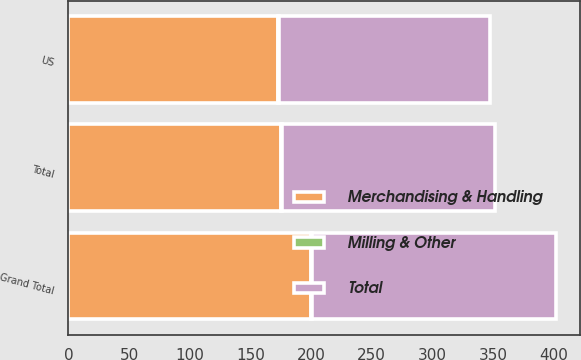Convert chart to OTSL. <chart><loc_0><loc_0><loc_500><loc_500><stacked_bar_chart><ecel><fcel>US<fcel>Total<fcel>Grand Total<nl><fcel>Merchandising & Handling<fcel>173<fcel>175<fcel>200<nl><fcel>Milling & Other<fcel>1<fcel>1<fcel>1<nl><fcel>Total<fcel>174<fcel>176<fcel>201<nl></chart> 